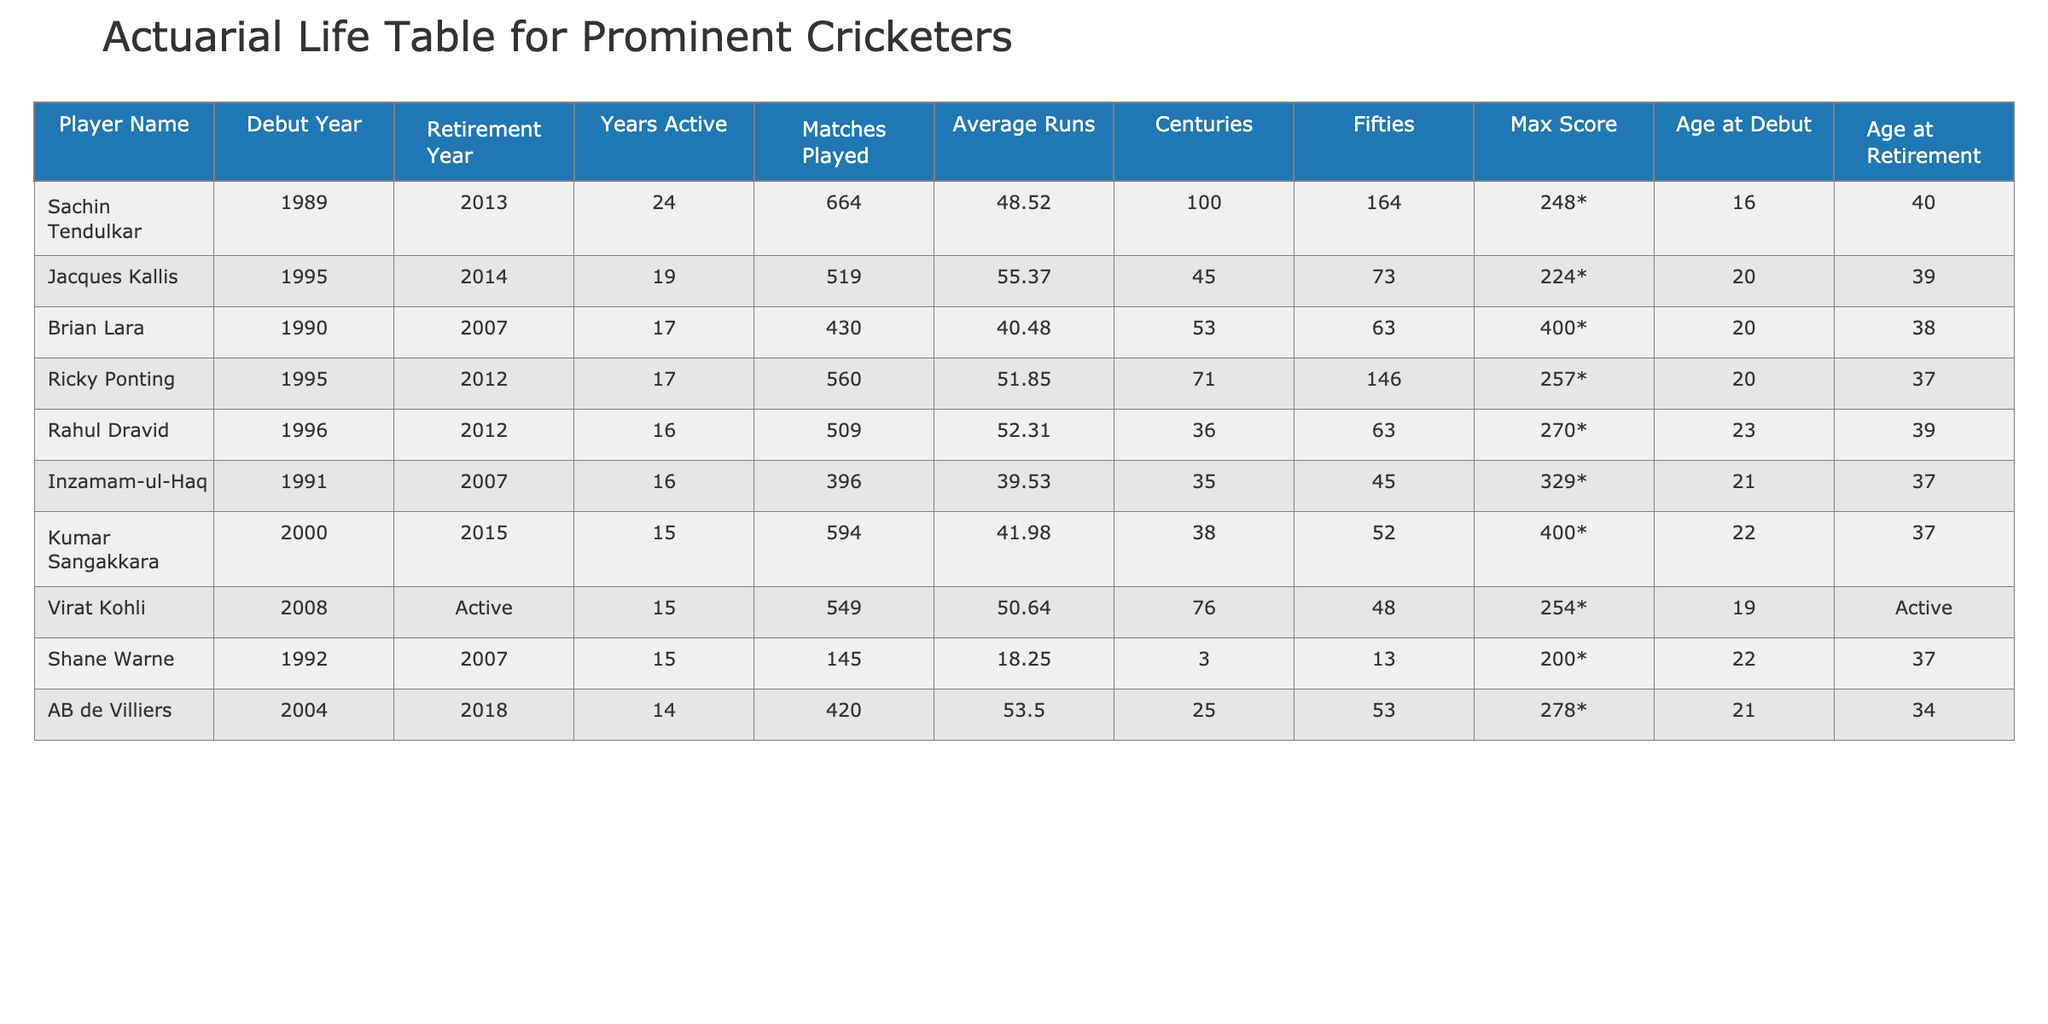What is the maximum score achieved by Sachin Tendulkar? From the table, we look at Sachin Tendulkar's row where the 'Max Score' column is listed as '248*', indicating that this is the highest score he achieved in his career.
Answer: 248* How many years did Brian Lara play international cricket? Referring to the table, we can see Brian Lara's row where 'Years Active' is specified as '17', meaning he played for 17 years.
Answer: 17 Who has the highest average runs among the players listed? To determine who has the highest average runs, we compare the 'Average Runs' column across all rows. Jacques Kallis has the highest average at '55.37'.
Answer: Jacques Kallis True or False: Ricky Ponting has more centuries than Rahul Dravid. Checking the 'Centuries' column, Ricky Ponting has '71' centuries while Rahul Dravid has '36'. Since 71 is greater than 36, the statement is True.
Answer: True What is the total number of matches played by all cricketers combined in the table? We sum the 'Matches Played' for each player: 664 + 430 + 519 + 560 + 594 + 549 + 396 + 145 + 420 = 3,677. Therefore, the total is 3,677 matches.
Answer: 3677 Who has the longest career span based on the 'Years Active'? By examining the 'Years Active' column, we find that Sachin Tendulkar played for 24 years, which is the longest in the table.
Answer: Sachin Tendulkar What is the age difference between the youngest debut player and the oldest retiree? The youngest age at debut is 16 (Sachin Tendulkar) and the oldest age at retirement is 40 (Sachin Tendulkar). The difference is 40 - 16 = 24 years.
Answer: 24 Which player has the same number of fifties as Ricky Ponting? Looking at the 'Fifties' column, both Ricky Ponting and Brian Lara have '63' fifties, meaning they are tied in this statistic.
Answer: Brian Lara How many cricketers had their careers end after the age of 39? We look at the 'Age at Retirement' column and find that Sachin Tendulkar (40), Jacques Kallis (39), and Rahul Dravid (39) retired after age 39, which totals to three players.
Answer: 3 